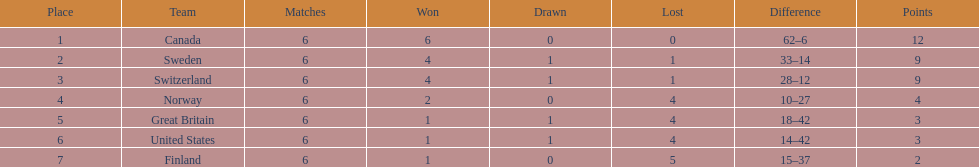How many teams won 6 matches? 1. 